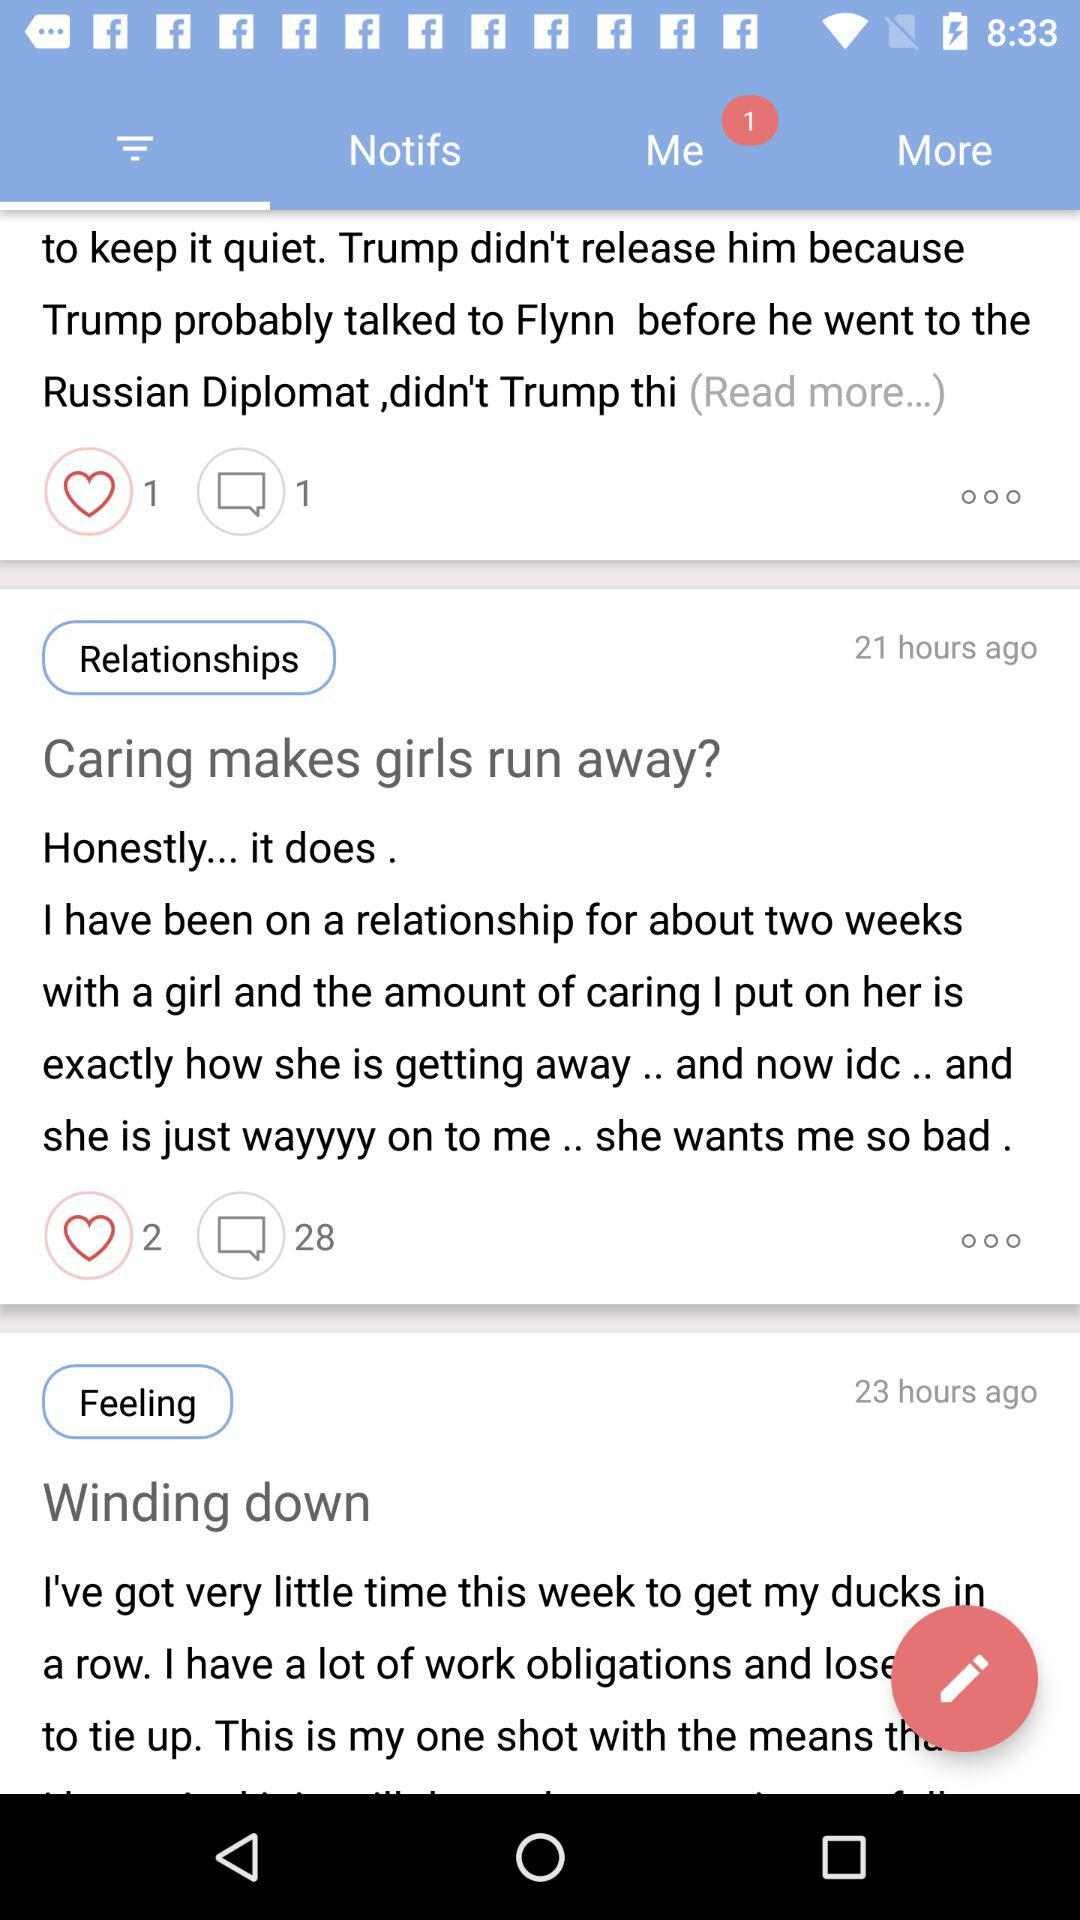How many comments are there for the article titled "Caring makes girls run away?"? There are 28 comments. 